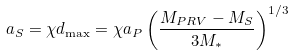<formula> <loc_0><loc_0><loc_500><loc_500>a _ { S } = \chi d _ { \max } = \chi a _ { P } \left ( \frac { M _ { P R V } - M _ { S } } { 3 M _ { * } } \right ) ^ { 1 / 3 }</formula> 